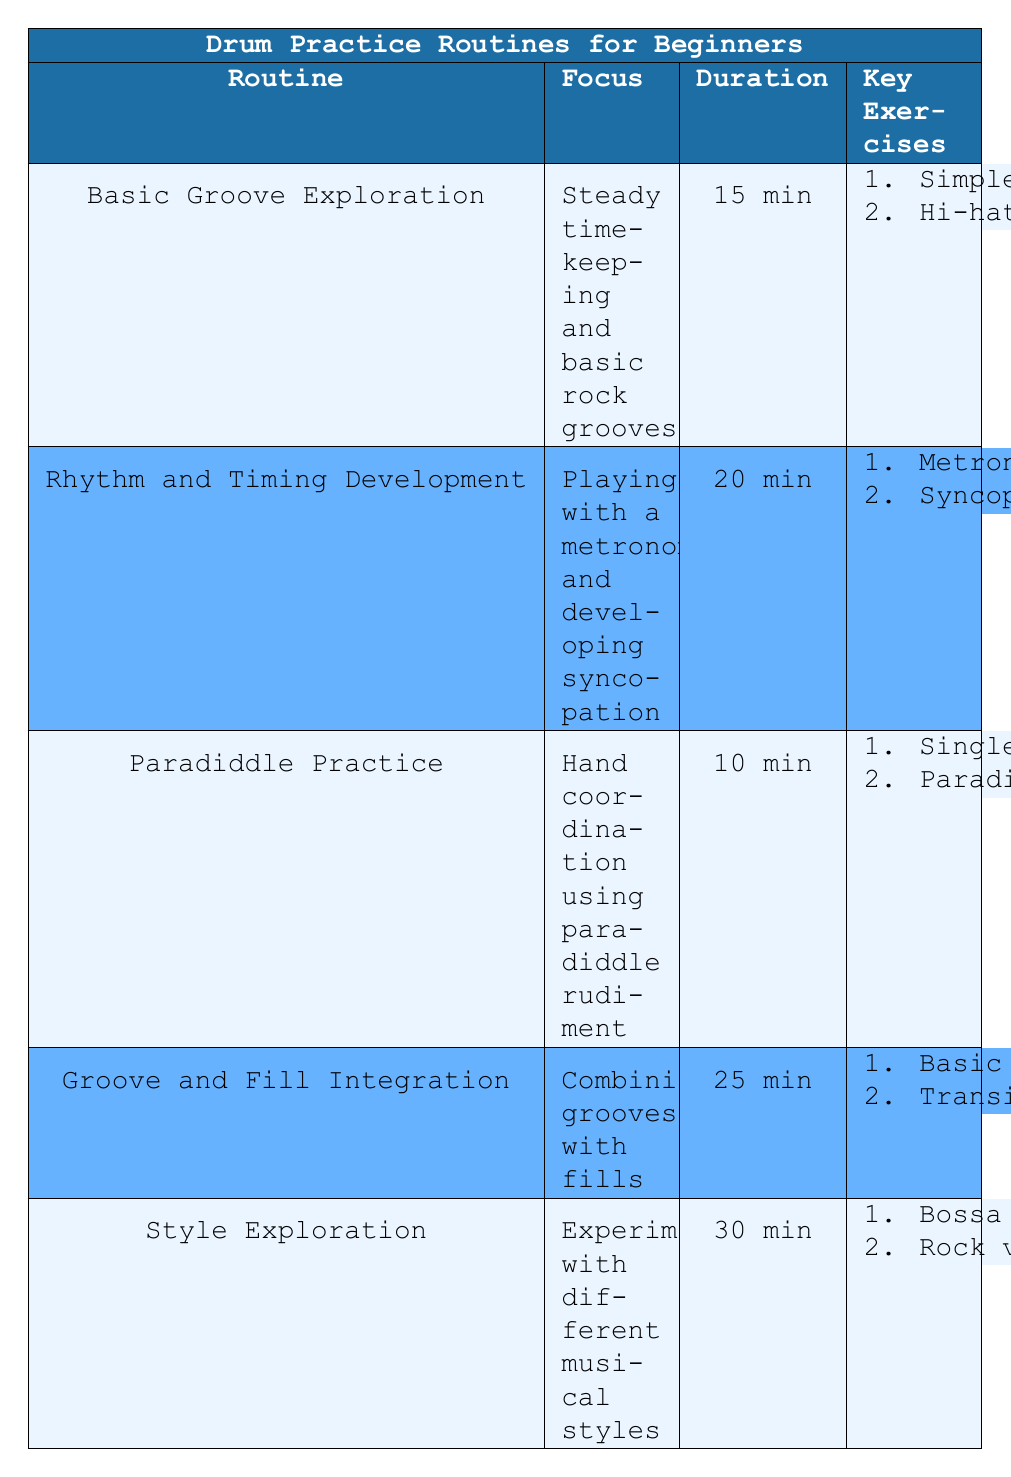What is the focus of the "Basic Groove Exploration" routine? The focus of the "Basic Groove Exploration" routine is listed in the table under the focus column, which states "Steady timekeeping and basic rock grooves."
Answer: Steady timekeeping and basic rock grooves How long is the "Rhythm and Timing Development" routine? The duration of the "Rhythm and Timing Development" routine is found in the duration column of the table, which shows "20 min."
Answer: 20 min Which routine has the shortest duration? To determine the routine with the shortest duration, I compare the durations in the duration column: 15 min, 20 min, 10 min, 25 min, and 30 min. The shortest duration is 10 min for the "Paradiddle Practice" routine.
Answer: Paradiddle Practice What exercises are included in the "Style Exploration" routine? According to the table, the key exercises for the "Style Exploration" routine are listed under the key exercises column: "1. Bossa Nova Rhythms" and "2. Rock versus Jazz grooves."
Answer: 1. Bossa Nova Rhythms; 2. Rock versus Jazz grooves Is there a routine focused solely on hand coordination? Looking under the focus column, we see that the "Paradiddle Practice" routine is specifically focused on "Hand coordination using paradiddle rudiment." Therefore, it is true that there is a routine focused solely on hand coordination.
Answer: Yes What is the total duration of the "Groove and Fill Integration" and "Style Exploration" routines combined? To find the total duration, I add the durations of both routines from the duration column: "Groove and Fill Integration" is 25 min and "Style Exploration" is 30 min. So, 25 + 30 = 55 min.
Answer: 55 min Which routine requires the most time to complete? By examining the duration column, I compare all the listed durations: 15 min, 20 min, 10 min, 25 min, and 30 min. The longest duration is 30 min, which corresponds to the "Style Exploration" routine.
Answer: Style Exploration Are all routines longer than 10 minutes? I check the durations listed: 15 min, 20 min, 10 min, 25 min, and 30 min. Since "Paradiddle Practice" has a duration of 10 min, not all routines are longer than 10 minutes.
Answer: No What is the combined duration of all routines? To find the combined duration, I sum up all the durations from the duration column: 15 + 20 + 10 + 25 + 30 = 100 min, giving a total combined duration.
Answer: 100 min 